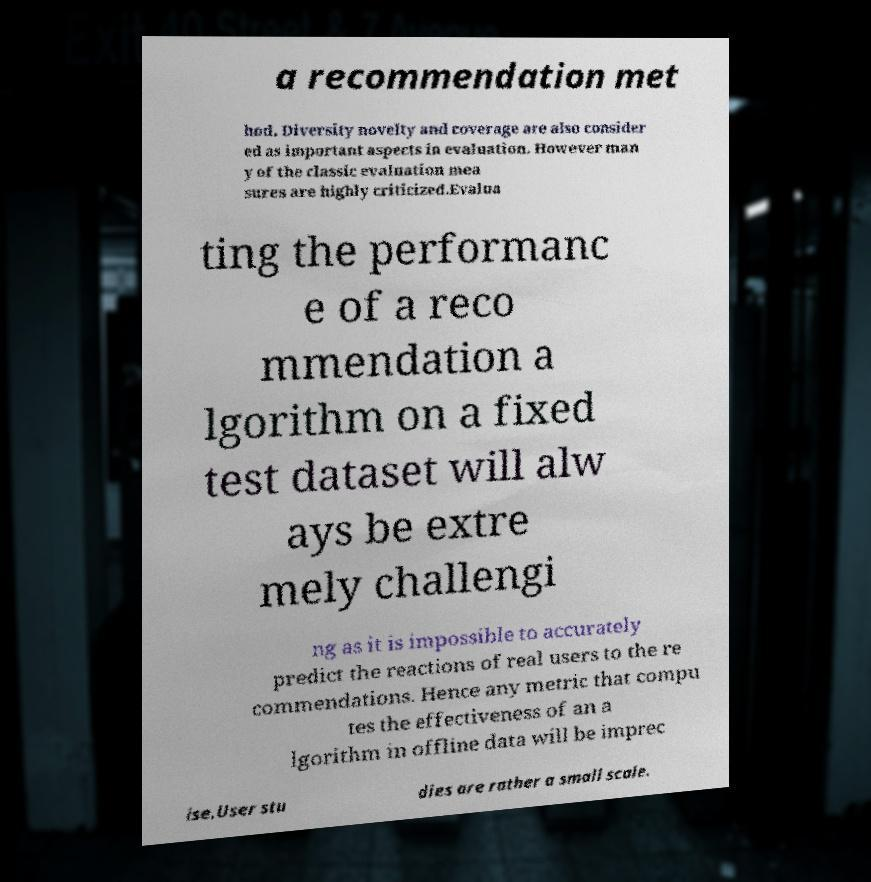Please read and relay the text visible in this image. What does it say? a recommendation met hod. Diversity novelty and coverage are also consider ed as important aspects in evaluation. However man y of the classic evaluation mea sures are highly criticized.Evalua ting the performanc e of a reco mmendation a lgorithm on a fixed test dataset will alw ays be extre mely challengi ng as it is impossible to accurately predict the reactions of real users to the re commendations. Hence any metric that compu tes the effectiveness of an a lgorithm in offline data will be imprec ise.User stu dies are rather a small scale. 